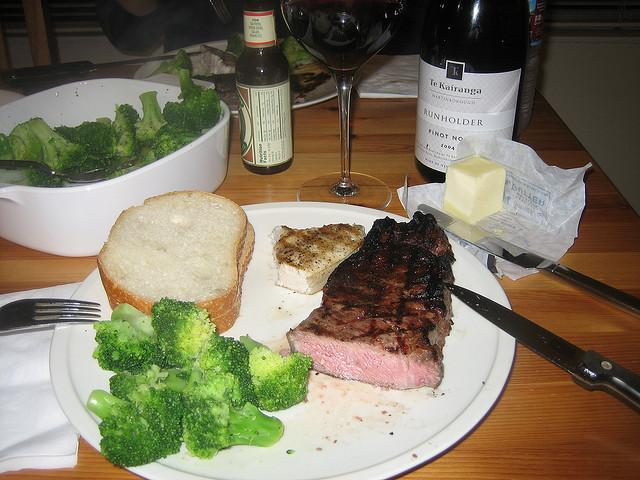How is this steak cooked? Please explain your reasoning. medium. There is some pink showing. 